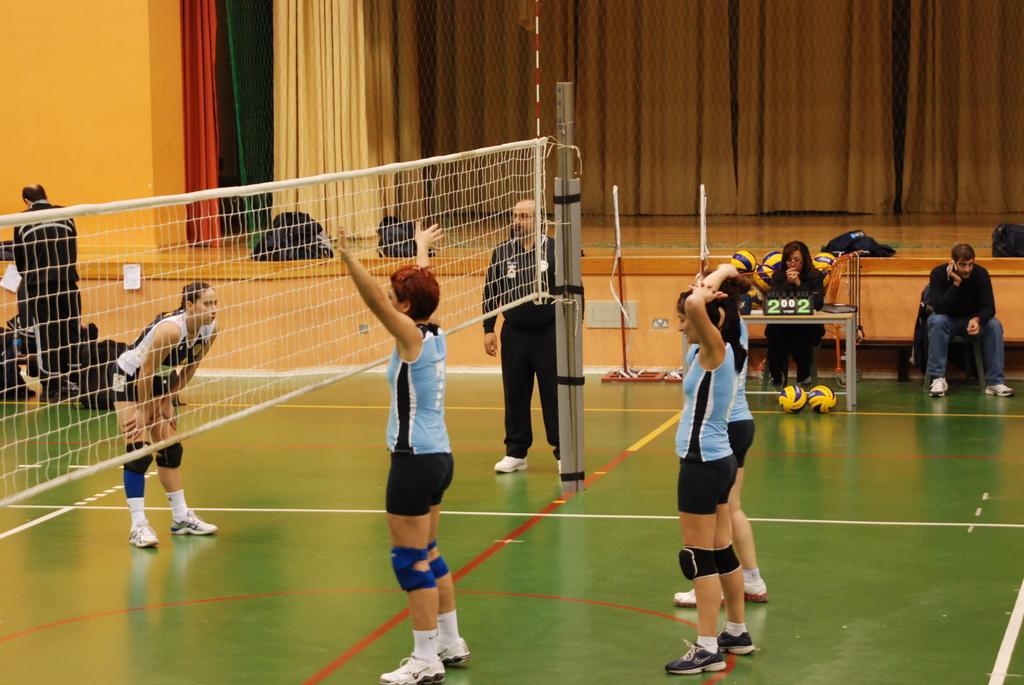In one or two sentences, can you explain what this image depicts? In this picture we can observe a volleyball court. There are some women playing volleyball. There is a net in the middle of the court. We can observe a person wearing black color dress near the pole. There are two members sitting on the right side. The court is in green color. In the background we can observe cream color curtains and a stage. 